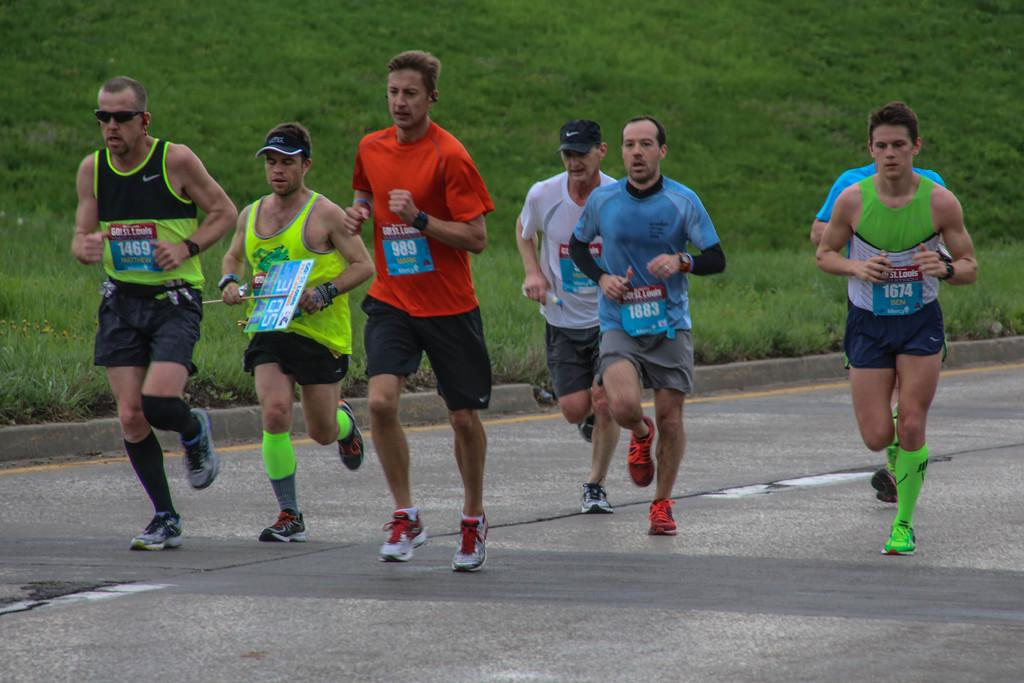Where was the image taken? The image was taken outside. What type of vegetation can be seen in the image? There is grass in the middle of the image. What are the people in the image doing? The people in the image are running in the middle of the image. What type of garden can be seen in the image? There is no garden present in the image; it features grass and people running. How many wings can be seen on the people running in the image? The people running in the image do not have wings; they are regular people. 